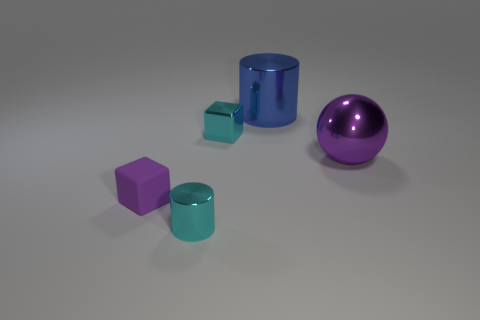Add 5 small purple matte spheres. How many objects exist? 10 Subtract all cyan cylinders. How many cylinders are left? 1 Subtract all cylinders. How many objects are left? 3 Add 4 spheres. How many spheres are left? 5 Add 2 tiny blue cubes. How many tiny blue cubes exist? 2 Subtract 0 yellow cylinders. How many objects are left? 5 Subtract all yellow spheres. Subtract all cyan cylinders. How many spheres are left? 1 Subtract all yellow cylinders. How many cyan blocks are left? 1 Subtract all large blue shiny cylinders. Subtract all cyan cubes. How many objects are left? 3 